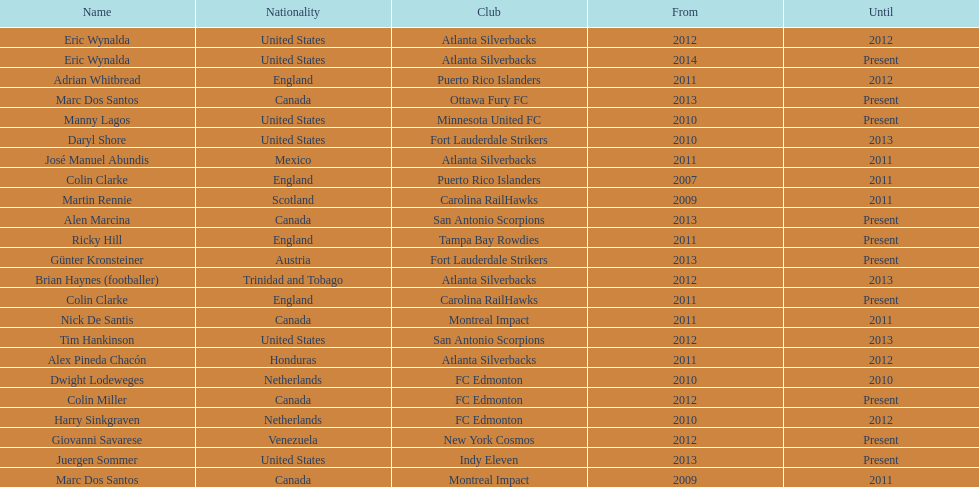Who is the last to coach the san antonio scorpions? Alen Marcina. 